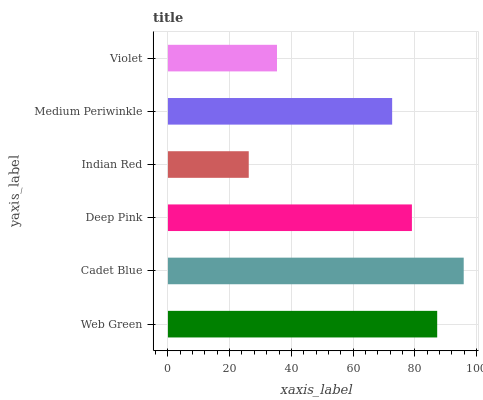Is Indian Red the minimum?
Answer yes or no. Yes. Is Cadet Blue the maximum?
Answer yes or no. Yes. Is Deep Pink the minimum?
Answer yes or no. No. Is Deep Pink the maximum?
Answer yes or no. No. Is Cadet Blue greater than Deep Pink?
Answer yes or no. Yes. Is Deep Pink less than Cadet Blue?
Answer yes or no. Yes. Is Deep Pink greater than Cadet Blue?
Answer yes or no. No. Is Cadet Blue less than Deep Pink?
Answer yes or no. No. Is Deep Pink the high median?
Answer yes or no. Yes. Is Medium Periwinkle the low median?
Answer yes or no. Yes. Is Cadet Blue the high median?
Answer yes or no. No. Is Indian Red the low median?
Answer yes or no. No. 